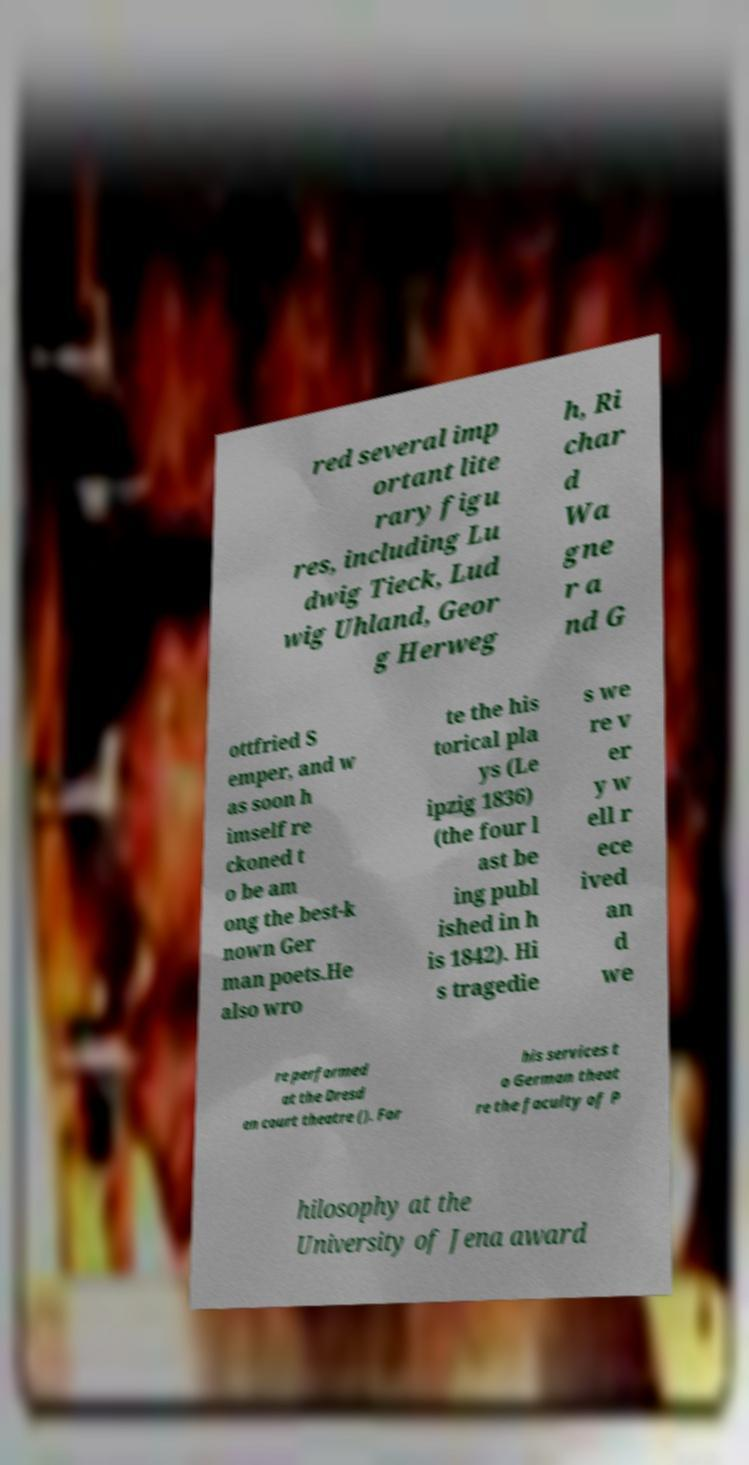There's text embedded in this image that I need extracted. Can you transcribe it verbatim? red several imp ortant lite rary figu res, including Lu dwig Tieck, Lud wig Uhland, Geor g Herweg h, Ri char d Wa gne r a nd G ottfried S emper, and w as soon h imself re ckoned t o be am ong the best-k nown Ger man poets.He also wro te the his torical pla ys (Le ipzig 1836) (the four l ast be ing publ ished in h is 1842). Hi s tragedie s we re v er y w ell r ece ived an d we re performed at the Dresd en court theatre (). For his services t o German theat re the faculty of P hilosophy at the University of Jena award 